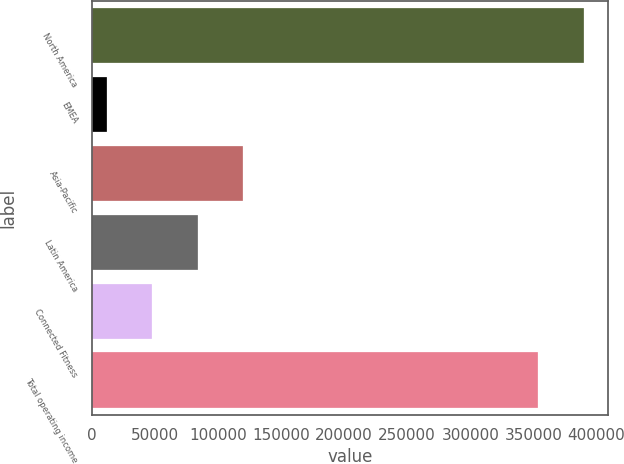<chart> <loc_0><loc_0><loc_500><loc_500><bar_chart><fcel>North America<fcel>EMEA<fcel>Asia-Pacific<fcel>Latin America<fcel>Connected Fitness<fcel>Total operating income<nl><fcel>390013<fcel>11763<fcel>119938<fcel>83879.8<fcel>47821.4<fcel>353955<nl></chart> 